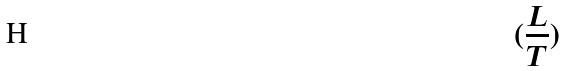<formula> <loc_0><loc_0><loc_500><loc_500>( \frac { L } { T } )</formula> 